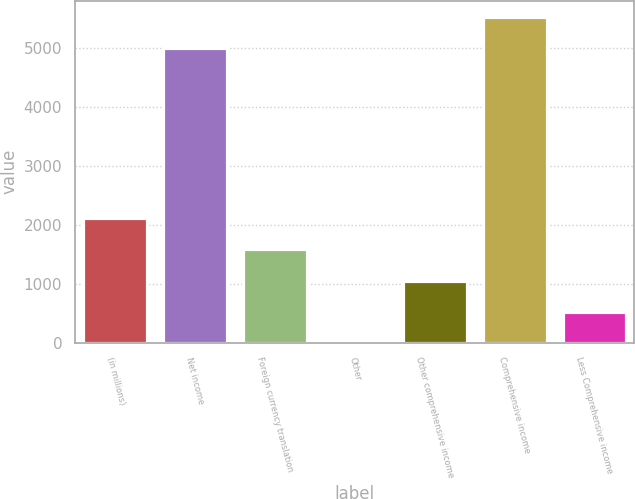Convert chart to OTSL. <chart><loc_0><loc_0><loc_500><loc_500><bar_chart><fcel>(in millions)<fcel>Net income<fcel>Foreign currency translation<fcel>Other<fcel>Other comprehensive income<fcel>Comprehensive income<fcel>Less Comprehensive income<nl><fcel>2117<fcel>5007<fcel>1588<fcel>1<fcel>1059<fcel>5536<fcel>530<nl></chart> 